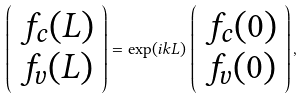Convert formula to latex. <formula><loc_0><loc_0><loc_500><loc_500>\left ( \begin{array} { c } f _ { c } ( L ) \\ f _ { v } ( L ) \end{array} \right ) = \exp ( i k L ) \, \left ( \begin{array} { c } f _ { c } ( 0 ) \\ f _ { v } ( 0 ) \end{array} \right ) ,</formula> 